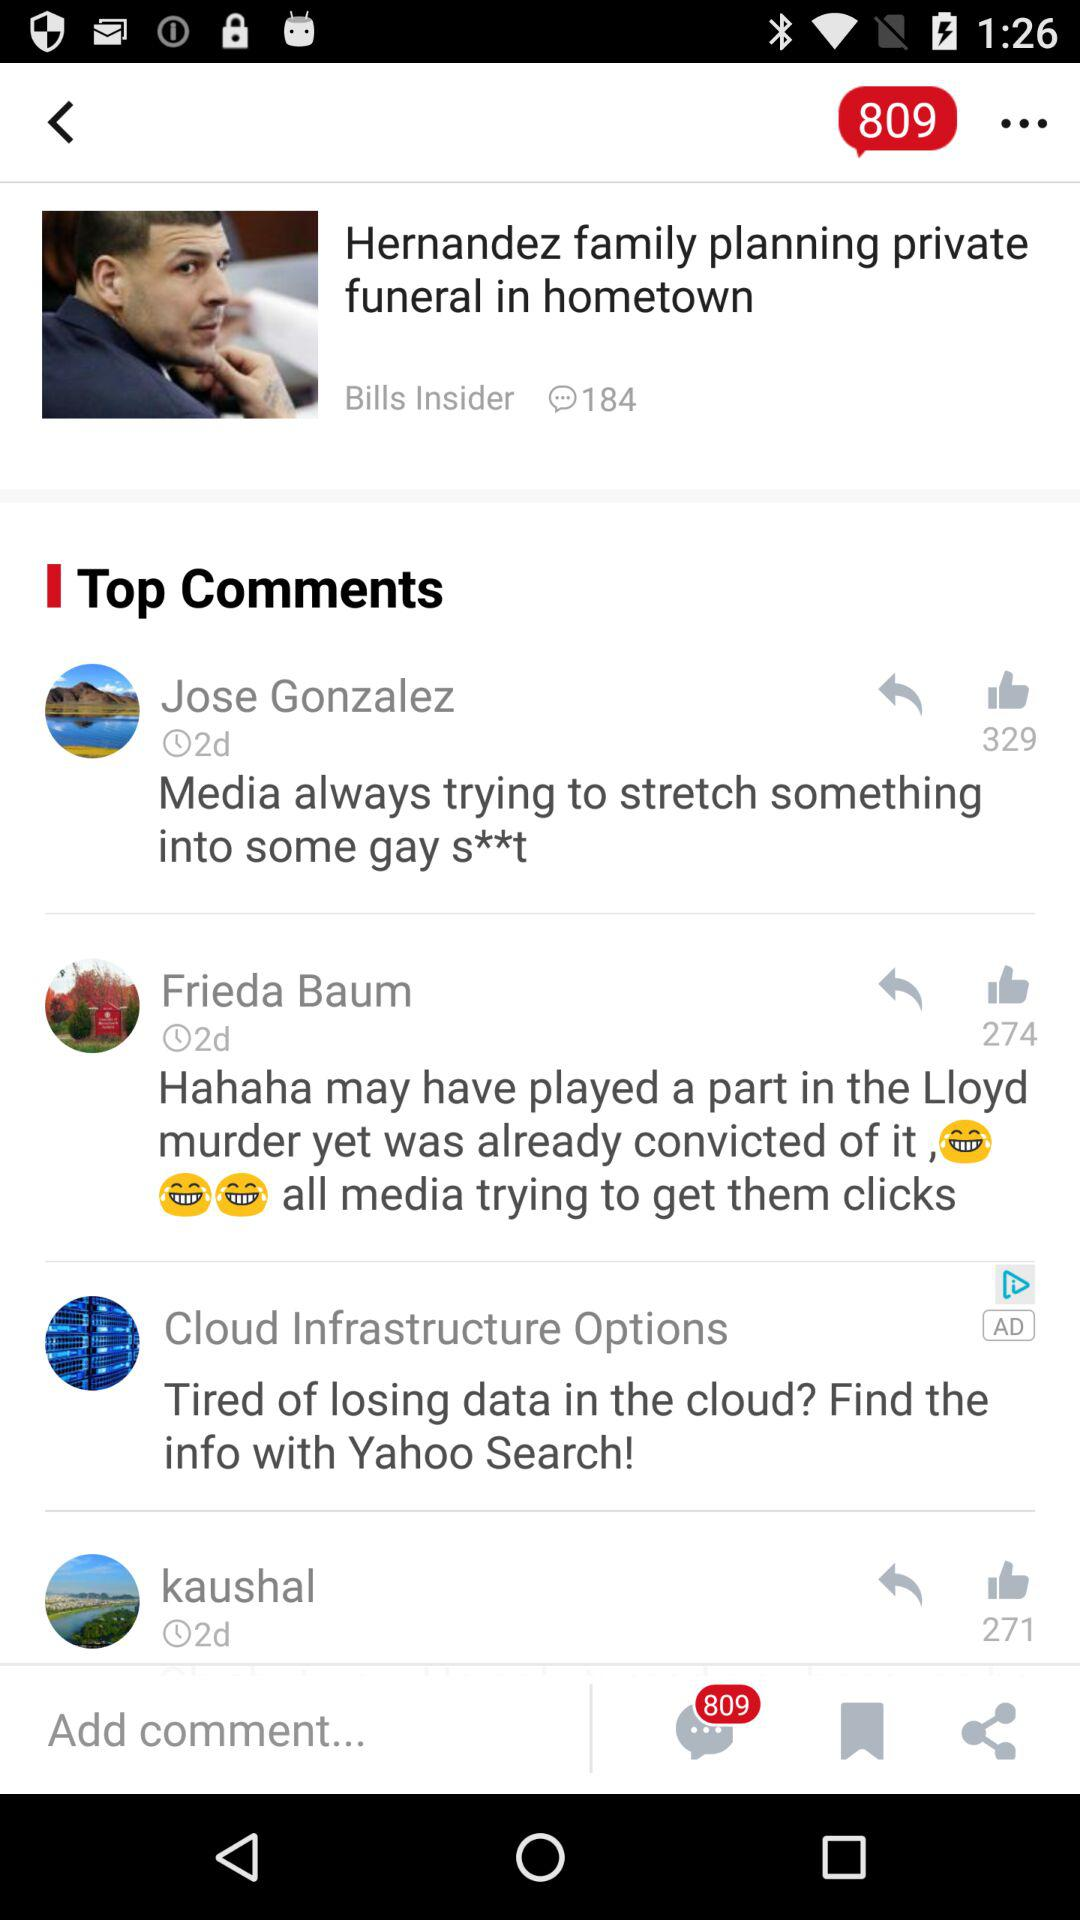How many unread comments are there? There are 809 unread comments. 